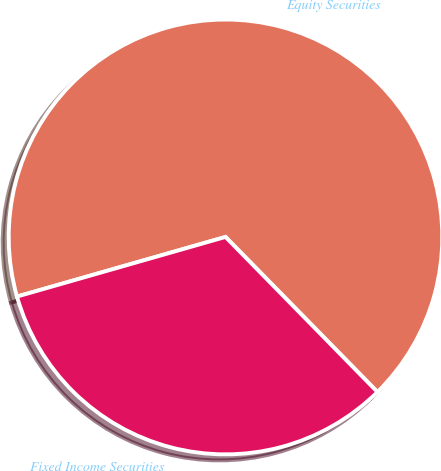Convert chart. <chart><loc_0><loc_0><loc_500><loc_500><pie_chart><fcel>Equity Securities<fcel>Fixed Income Securities<nl><fcel>67.06%<fcel>32.94%<nl></chart> 